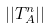<formula> <loc_0><loc_0><loc_500><loc_500>| | T _ { A } ^ { n } | |</formula> 